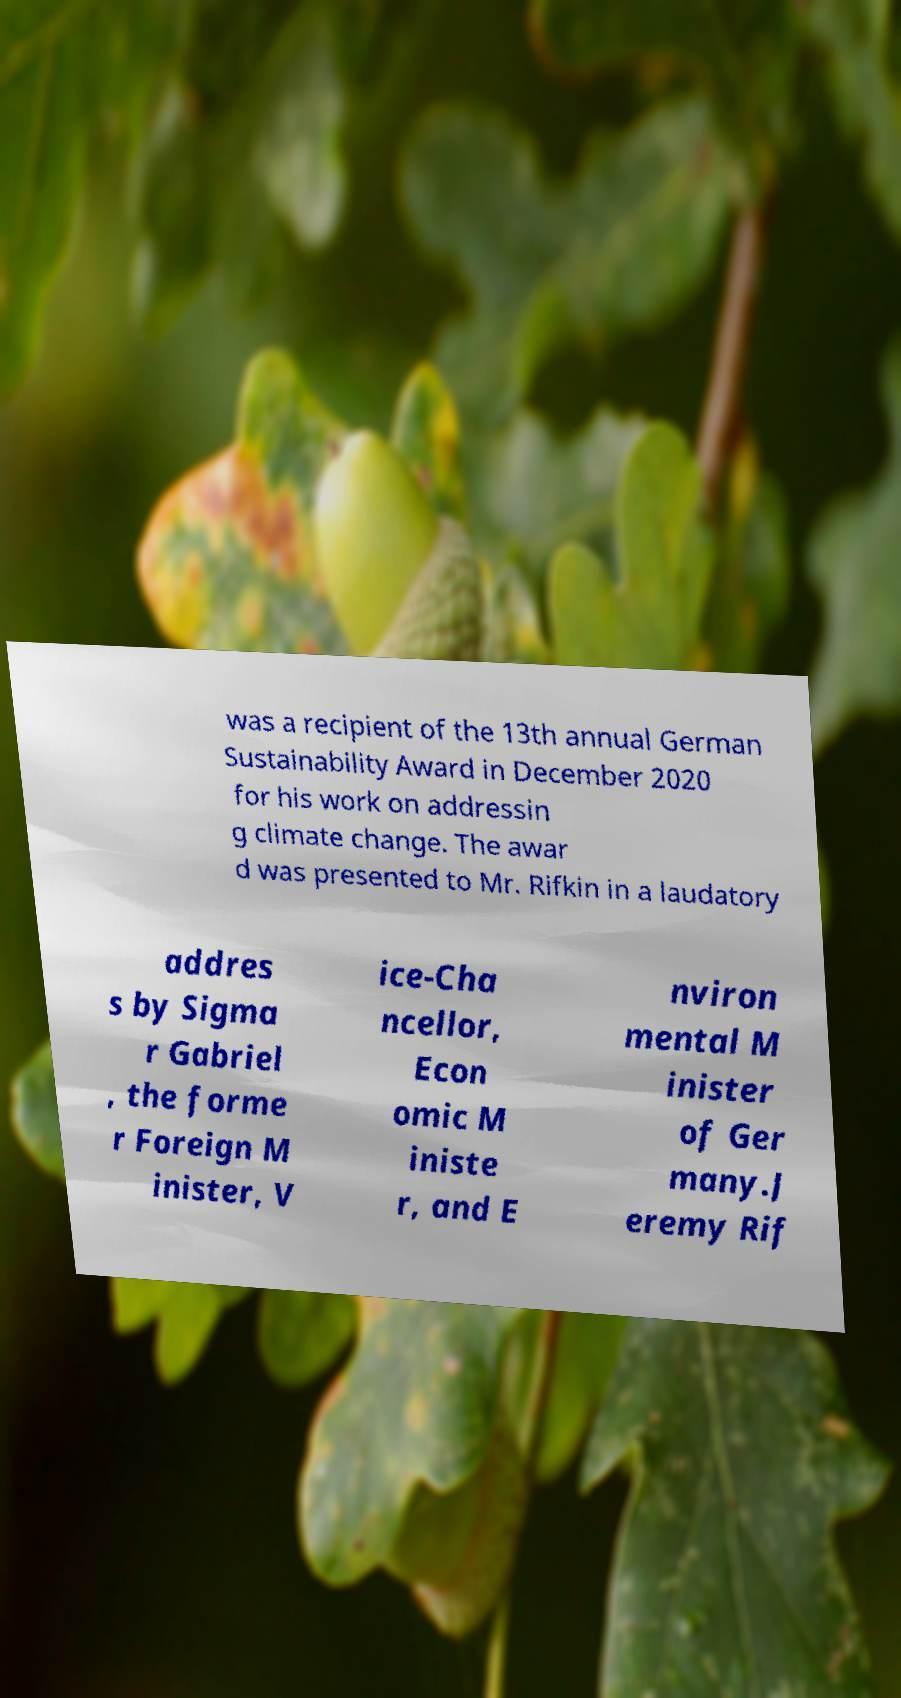For documentation purposes, I need the text within this image transcribed. Could you provide that? was a recipient of the 13th annual German Sustainability Award in December 2020 for his work on addressin g climate change. The awar d was presented to Mr. Rifkin in a laudatory addres s by Sigma r Gabriel , the forme r Foreign M inister, V ice-Cha ncellor, Econ omic M iniste r, and E nviron mental M inister of Ger many.J eremy Rif 